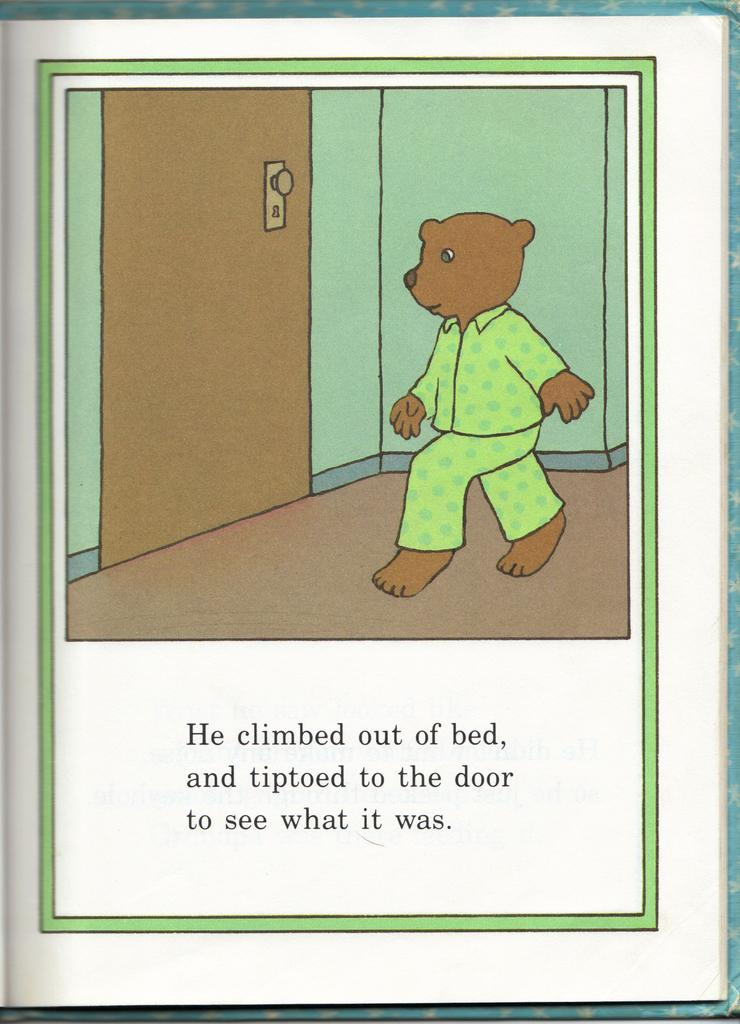What is the nature of the image? The image is edited. What object is present in the image? There is a teddy bear in the image. What is the teddy bear doing in the image? The teddy bear is walking in front of a door. Is there any text or description of the teddy bear's action in the image? Yes, the action of the teddy bear is mentioned in the image. What type of oatmeal is being offered to the teddy bear in the image? There is no oatmeal present in the image, nor is any food being offered to the teddy bear. 